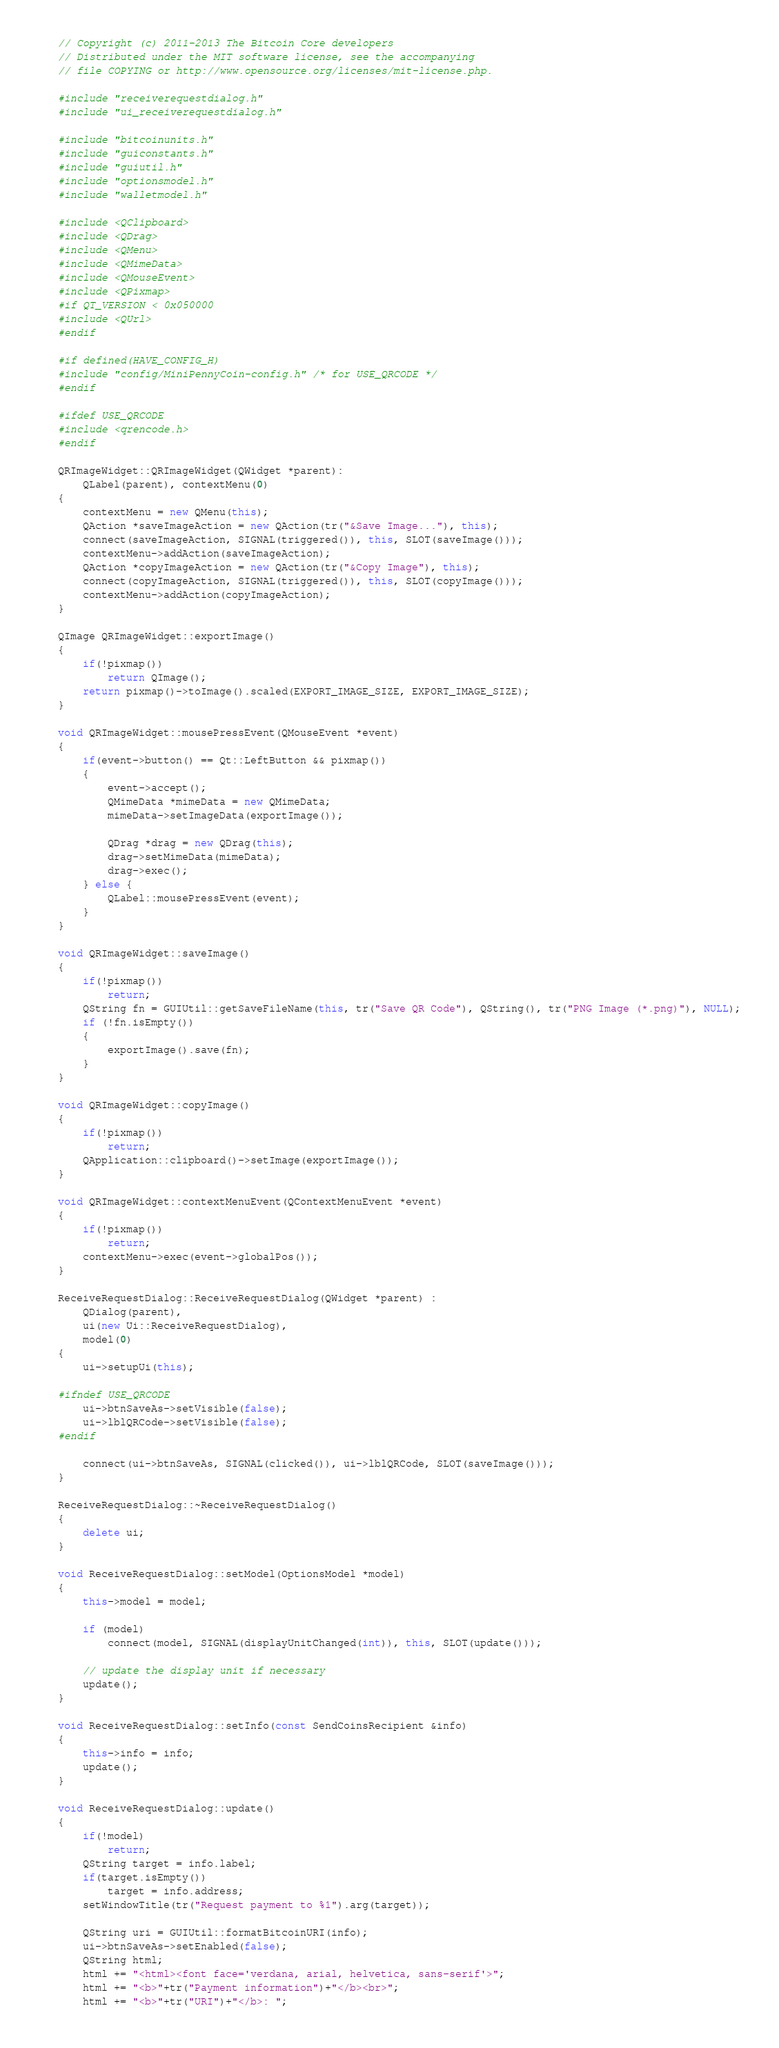<code> <loc_0><loc_0><loc_500><loc_500><_C++_>// Copyright (c) 2011-2013 The Bitcoin Core developers
// Distributed under the MIT software license, see the accompanying
// file COPYING or http://www.opensource.org/licenses/mit-license.php.

#include "receiverequestdialog.h"
#include "ui_receiverequestdialog.h"

#include "bitcoinunits.h"
#include "guiconstants.h"
#include "guiutil.h"
#include "optionsmodel.h"
#include "walletmodel.h"

#include <QClipboard>
#include <QDrag>
#include <QMenu>
#include <QMimeData>
#include <QMouseEvent>
#include <QPixmap>
#if QT_VERSION < 0x050000
#include <QUrl>
#endif

#if defined(HAVE_CONFIG_H)
#include "config/MiniPennyCoin-config.h" /* for USE_QRCODE */
#endif

#ifdef USE_QRCODE
#include <qrencode.h>
#endif

QRImageWidget::QRImageWidget(QWidget *parent):
    QLabel(parent), contextMenu(0)
{
    contextMenu = new QMenu(this);
    QAction *saveImageAction = new QAction(tr("&Save Image..."), this);
    connect(saveImageAction, SIGNAL(triggered()), this, SLOT(saveImage()));
    contextMenu->addAction(saveImageAction);
    QAction *copyImageAction = new QAction(tr("&Copy Image"), this);
    connect(copyImageAction, SIGNAL(triggered()), this, SLOT(copyImage()));
    contextMenu->addAction(copyImageAction);
}

QImage QRImageWidget::exportImage()
{
    if(!pixmap())
        return QImage();
    return pixmap()->toImage().scaled(EXPORT_IMAGE_SIZE, EXPORT_IMAGE_SIZE);
}

void QRImageWidget::mousePressEvent(QMouseEvent *event)
{
    if(event->button() == Qt::LeftButton && pixmap())
    {
        event->accept();
        QMimeData *mimeData = new QMimeData;
        mimeData->setImageData(exportImage());

        QDrag *drag = new QDrag(this);
        drag->setMimeData(mimeData);
        drag->exec();
    } else {
        QLabel::mousePressEvent(event);
    }
}

void QRImageWidget::saveImage()
{
    if(!pixmap())
        return;
    QString fn = GUIUtil::getSaveFileName(this, tr("Save QR Code"), QString(), tr("PNG Image (*.png)"), NULL);
    if (!fn.isEmpty())
    {
        exportImage().save(fn);
    }
}

void QRImageWidget::copyImage()
{
    if(!pixmap())
        return;
    QApplication::clipboard()->setImage(exportImage());
}

void QRImageWidget::contextMenuEvent(QContextMenuEvent *event)
{
    if(!pixmap())
        return;
    contextMenu->exec(event->globalPos());
}

ReceiveRequestDialog::ReceiveRequestDialog(QWidget *parent) :
    QDialog(parent),
    ui(new Ui::ReceiveRequestDialog),
    model(0)
{
    ui->setupUi(this);

#ifndef USE_QRCODE
    ui->btnSaveAs->setVisible(false);
    ui->lblQRCode->setVisible(false);
#endif

    connect(ui->btnSaveAs, SIGNAL(clicked()), ui->lblQRCode, SLOT(saveImage()));
}

ReceiveRequestDialog::~ReceiveRequestDialog()
{
    delete ui;
}

void ReceiveRequestDialog::setModel(OptionsModel *model)
{
    this->model = model;

    if (model)
        connect(model, SIGNAL(displayUnitChanged(int)), this, SLOT(update()));

    // update the display unit if necessary
    update();
}

void ReceiveRequestDialog::setInfo(const SendCoinsRecipient &info)
{
    this->info = info;
    update();
}

void ReceiveRequestDialog::update()
{
    if(!model)
        return;
    QString target = info.label;
    if(target.isEmpty())
        target = info.address;
    setWindowTitle(tr("Request payment to %1").arg(target));

    QString uri = GUIUtil::formatBitcoinURI(info);
    ui->btnSaveAs->setEnabled(false);
    QString html;
    html += "<html><font face='verdana, arial, helvetica, sans-serif'>";
    html += "<b>"+tr("Payment information")+"</b><br>";
    html += "<b>"+tr("URI")+"</b>: ";</code> 